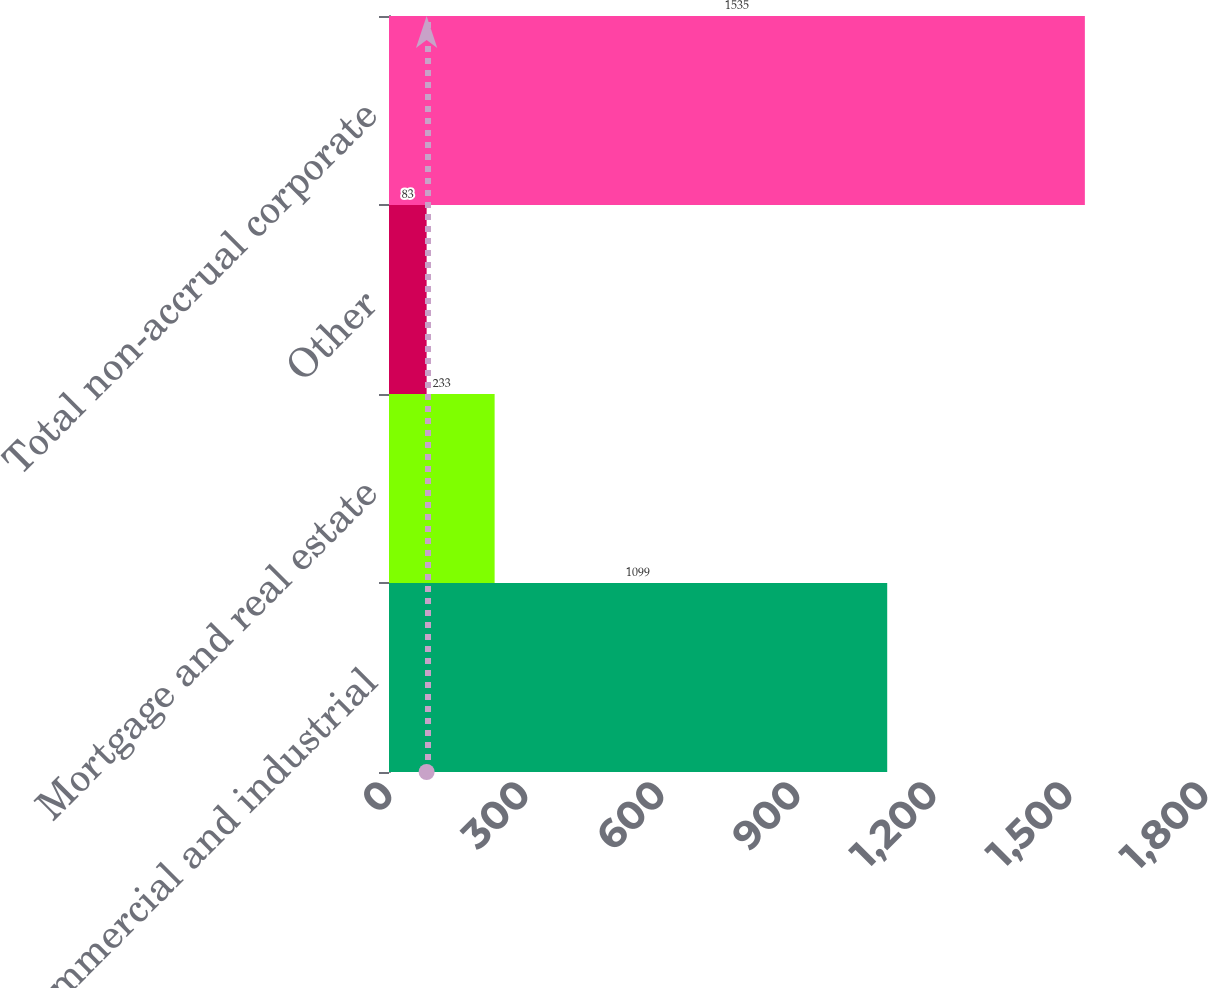Convert chart to OTSL. <chart><loc_0><loc_0><loc_500><loc_500><bar_chart><fcel>Commercial and industrial<fcel>Mortgage and real estate<fcel>Other<fcel>Total non-accrual corporate<nl><fcel>1099<fcel>233<fcel>83<fcel>1535<nl></chart> 